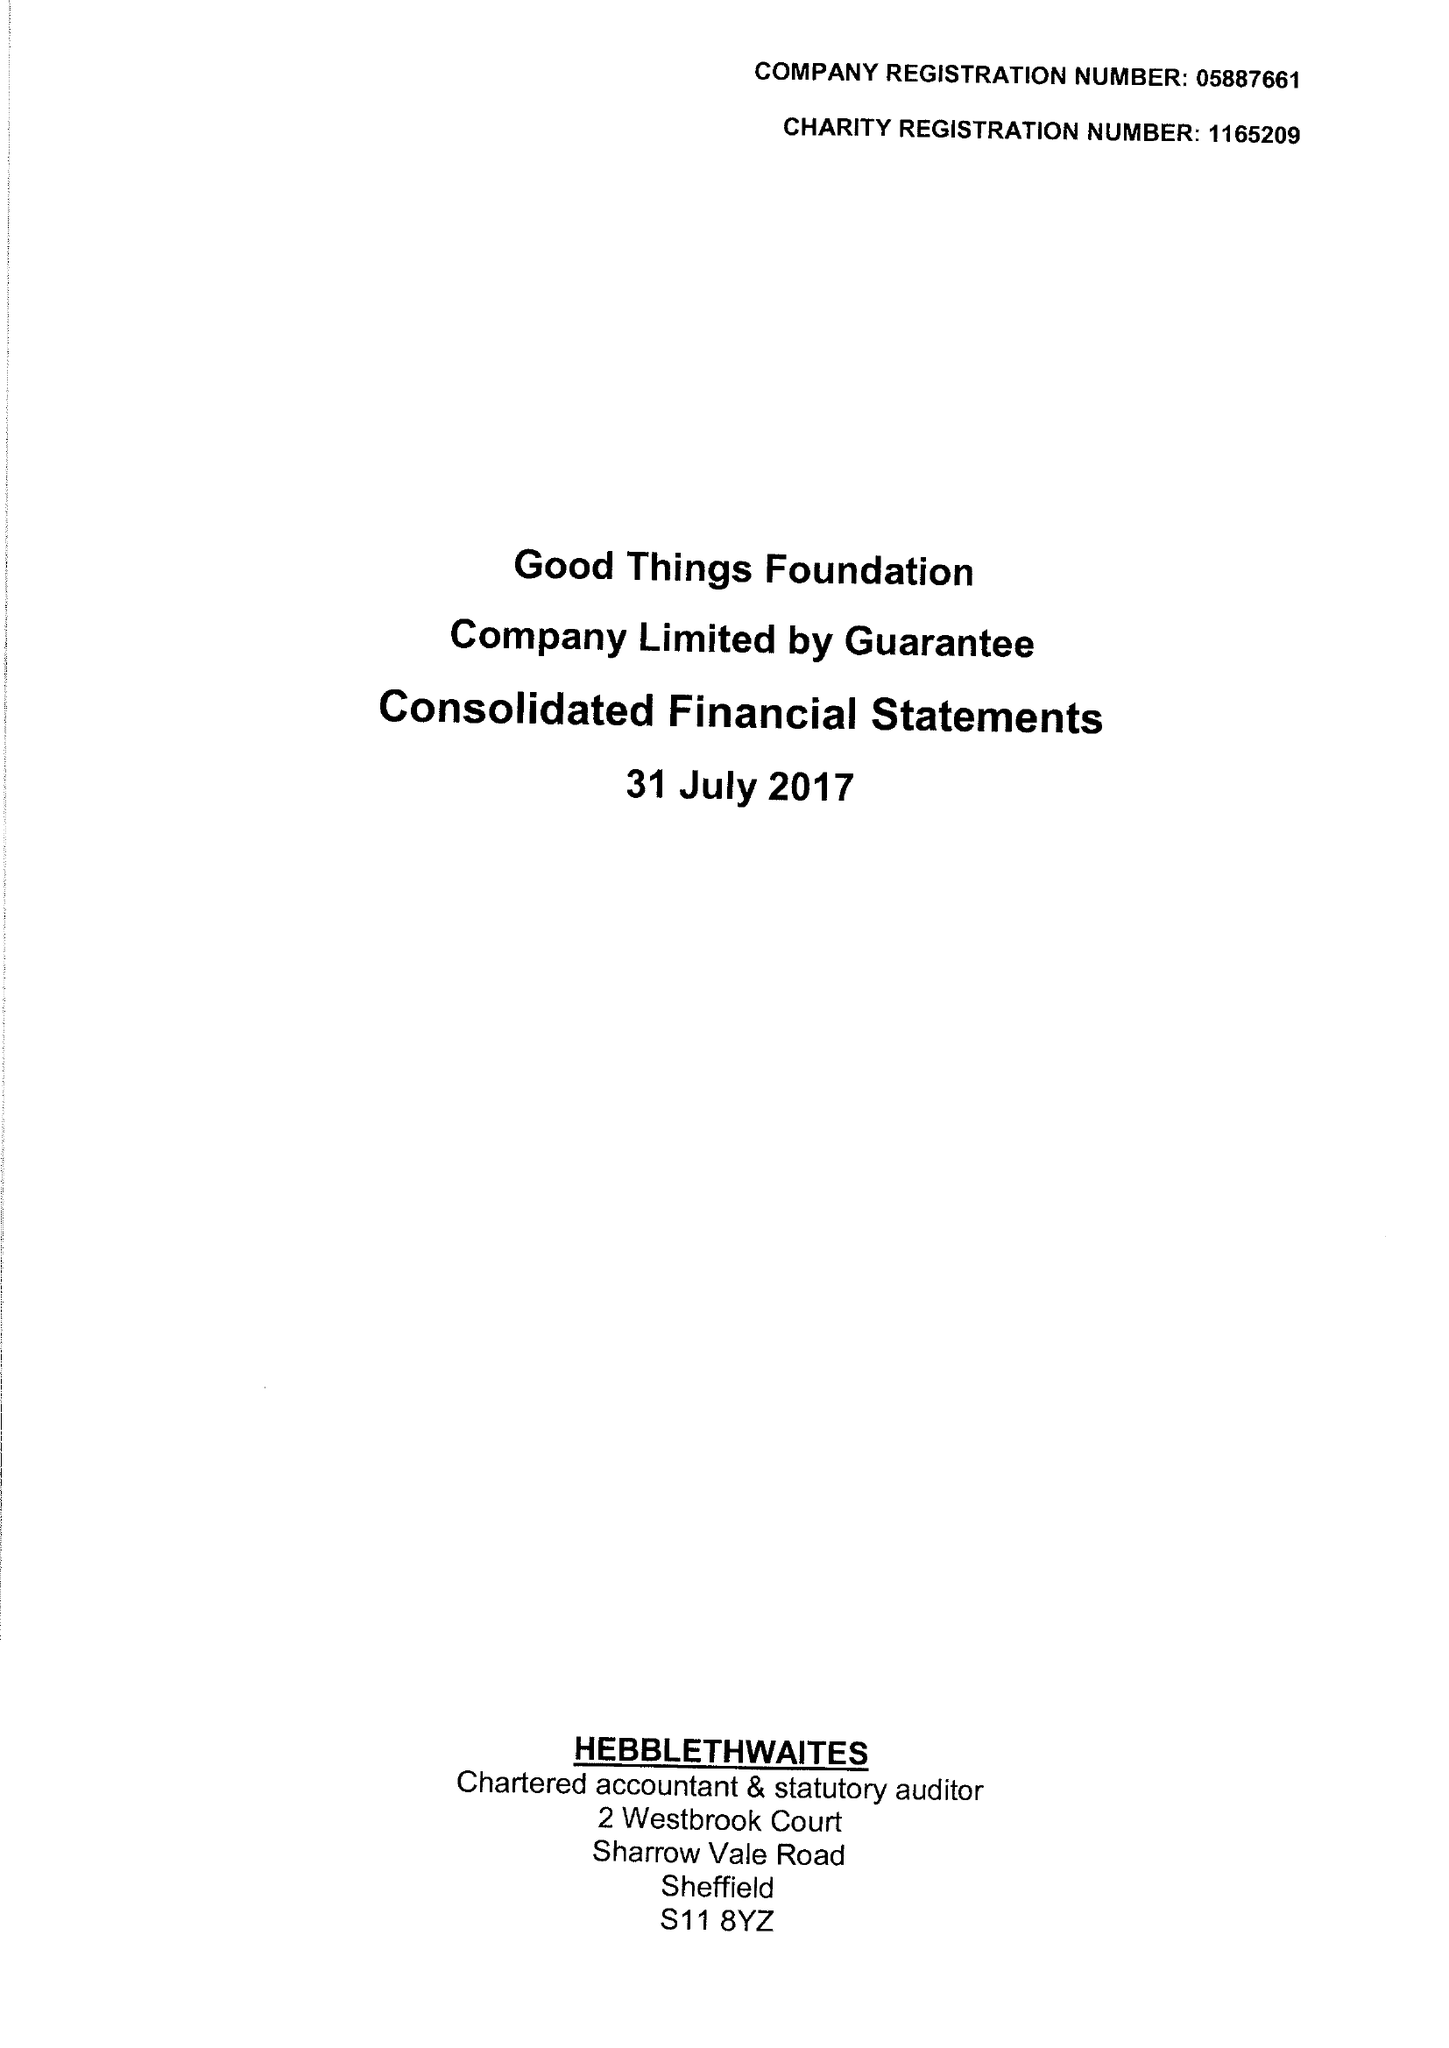What is the value for the address__street_line?
Answer the question using a single word or phrase. 1 EAST PARADE 